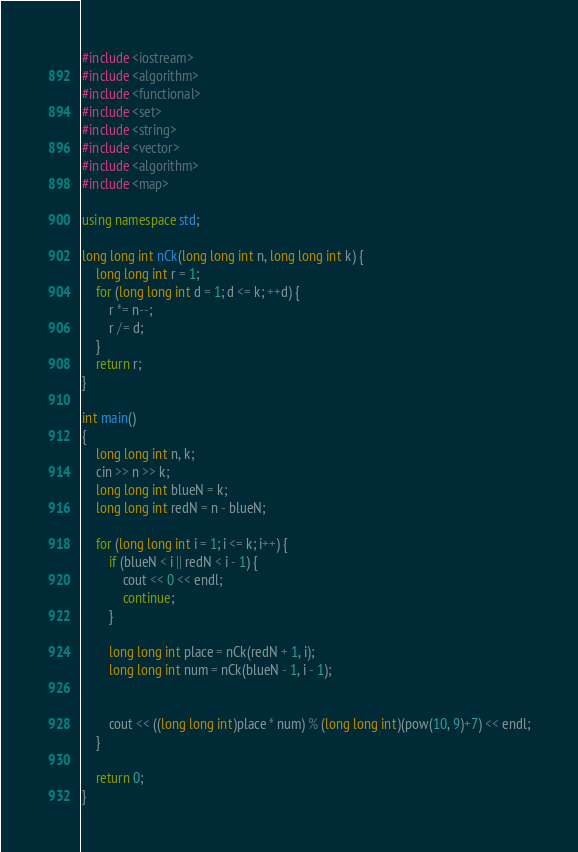<code> <loc_0><loc_0><loc_500><loc_500><_C++_>
#include <iostream>
#include <algorithm>
#include <functional>
#include <set>
#include <string>
#include <vector>
#include <algorithm>
#include <map>

using namespace std;

long long int nCk(long long int n, long long int k) {
	long long int r = 1;
	for (long long int d = 1; d <= k; ++d) {
		r *= n--;
		r /= d;
	}
	return r;
}

int main()
{
	long long int n, k;
	cin >> n >> k;
	long long int blueN = k;
	long long int redN = n - blueN;
	
	for (long long int i = 1; i <= k; i++) {
		if (blueN < i || redN < i - 1) {
			cout << 0 << endl;
			continue;
		}
			
		long long int place = nCk(redN + 1, i);
		long long int num = nCk(blueN - 1, i - 1);
		
		
		cout << ((long long int)place * num) % (long long int)(pow(10, 9)+7) << endl;
	}

	return 0;
}
</code> 